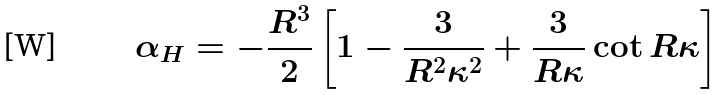<formula> <loc_0><loc_0><loc_500><loc_500>\alpha _ { H } = - \frac { R ^ { 3 } } { 2 } \left [ 1 - \frac { 3 } { R ^ { 2 } \kappa ^ { 2 } } + \frac { 3 } { R \kappa } \cot { R \kappa } \right ]</formula> 